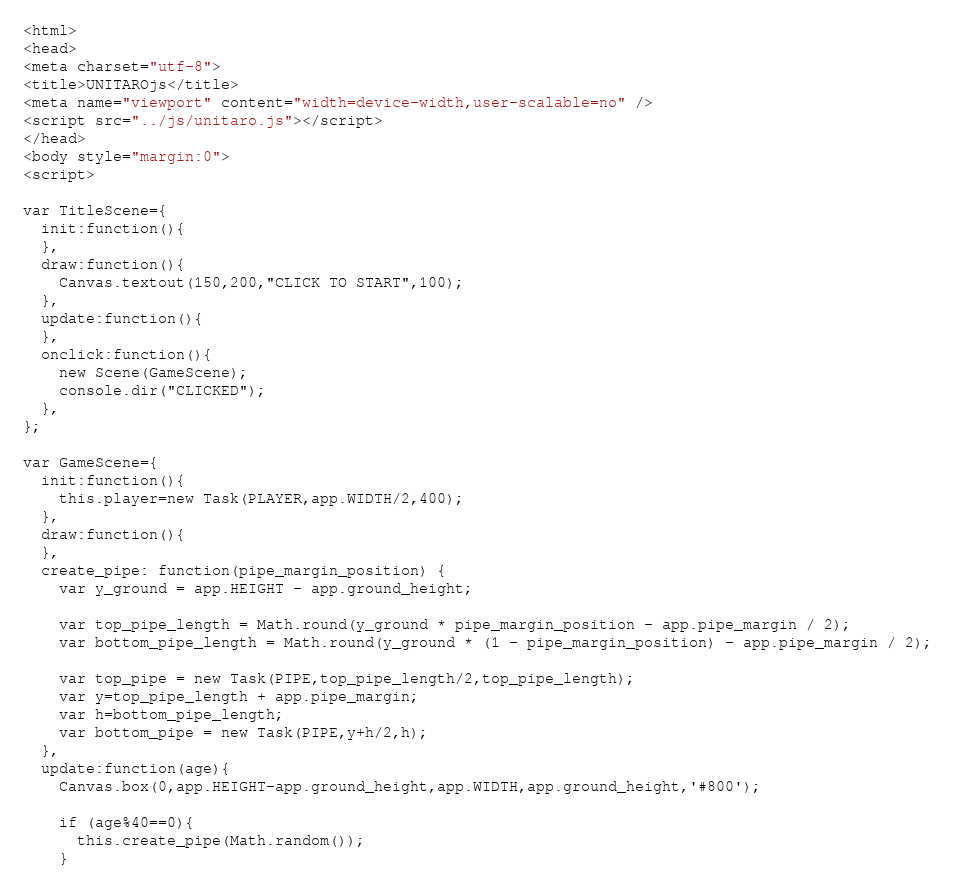Convert code to text. <code><loc_0><loc_0><loc_500><loc_500><_HTML_><html>
<head>
<meta charset="utf-8">
<title>UNITAROjs</title>
<meta name="viewport" content="width=device-width,user-scalable=no" />
<script src="../js/unitaro.js"></script>
</head>
<body style="margin:0">
<script>

var TitleScene={
  init:function(){
  },
  draw:function(){
    Canvas.textout(150,200,"CLICK TO START",100);
  },
  update:function(){
  },
  onclick:function(){
    new Scene(GameScene);
    console.dir("CLICKED");
  },
};

var GameScene={
  init:function(){
    this.player=new Task(PLAYER,app.WIDTH/2,400);
  },
  draw:function(){
  },
  create_pipe: function(pipe_margin_position) {
    var y_ground = app.HEIGHT - app.ground_height;

    var top_pipe_length = Math.round(y_ground * pipe_margin_position - app.pipe_margin / 2);
    var bottom_pipe_length = Math.round(y_ground * (1 - pipe_margin_position) - app.pipe_margin / 2);

    var top_pipe = new Task(PIPE,top_pipe_length/2,top_pipe_length);
    var y=top_pipe_length + app.pipe_margin;
    var h=bottom_pipe_length;
    var bottom_pipe = new Task(PIPE,y+h/2,h);
  },
  update:function(age){
    Canvas.box(0,app.HEIGHT-app.ground_height,app.WIDTH,app.ground_height,'#800');

    if (age%40==0){
      this.create_pipe(Math.random());
    }</code> 